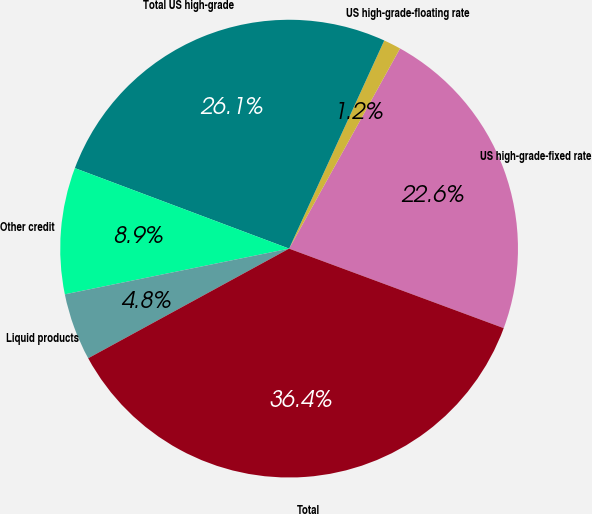Convert chart. <chart><loc_0><loc_0><loc_500><loc_500><pie_chart><fcel>US high-grade-fixed rate<fcel>US high-grade-floating rate<fcel>Total US high-grade<fcel>Other credit<fcel>Liquid products<fcel>Total<nl><fcel>22.59%<fcel>1.23%<fcel>26.1%<fcel>8.92%<fcel>4.75%<fcel>36.4%<nl></chart> 